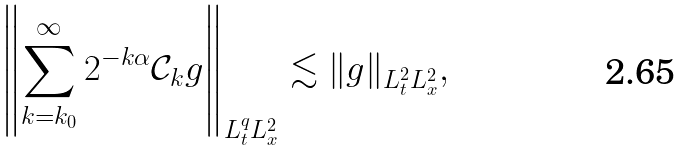<formula> <loc_0><loc_0><loc_500><loc_500>\left \| \sum _ { k = k _ { 0 } } ^ { \infty } 2 ^ { - k \alpha } \mathcal { C } _ { k } g \right \| _ { L ^ { q } _ { t } L ^ { 2 } _ { x } } \lesssim \| g \| _ { L ^ { 2 } _ { t } L ^ { 2 } _ { x } } ,</formula> 